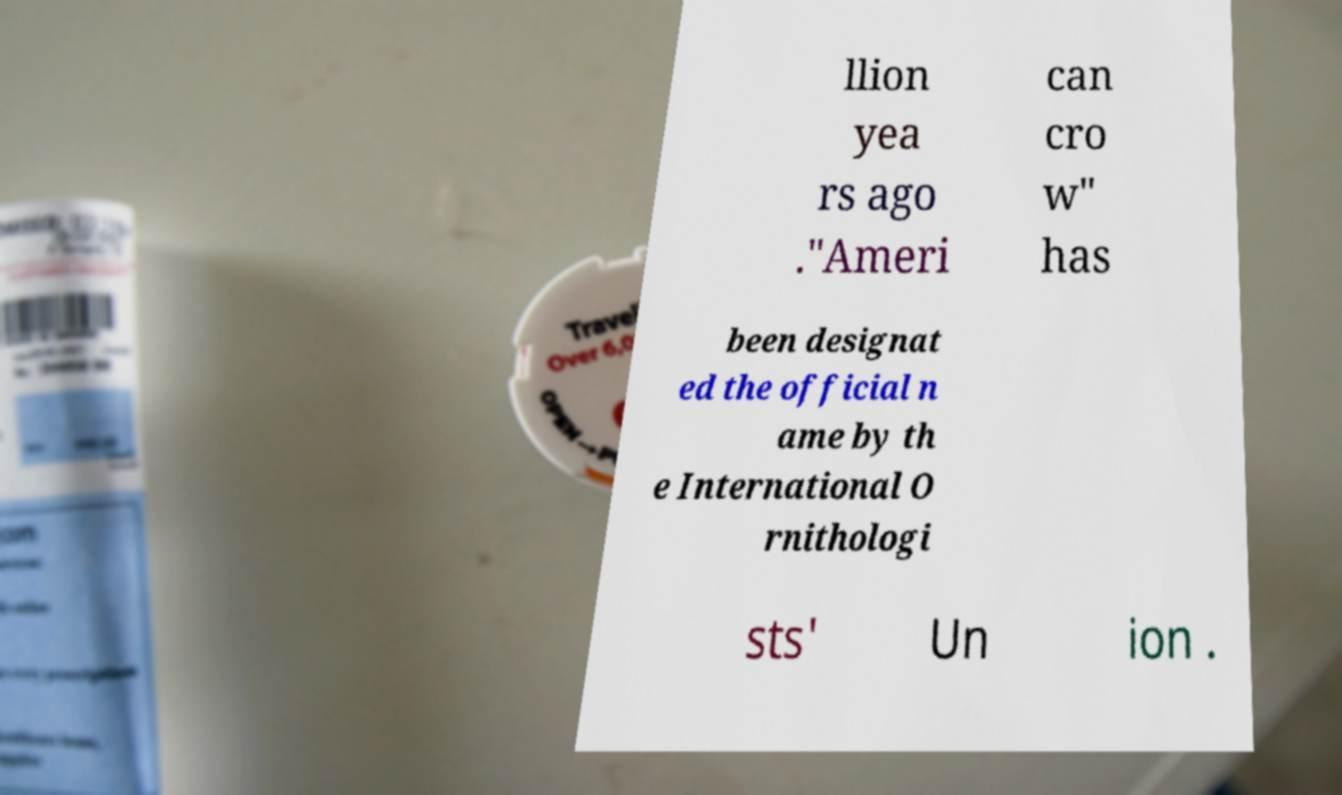Could you assist in decoding the text presented in this image and type it out clearly? llion yea rs ago ."Ameri can cro w" has been designat ed the official n ame by th e International O rnithologi sts' Un ion . 